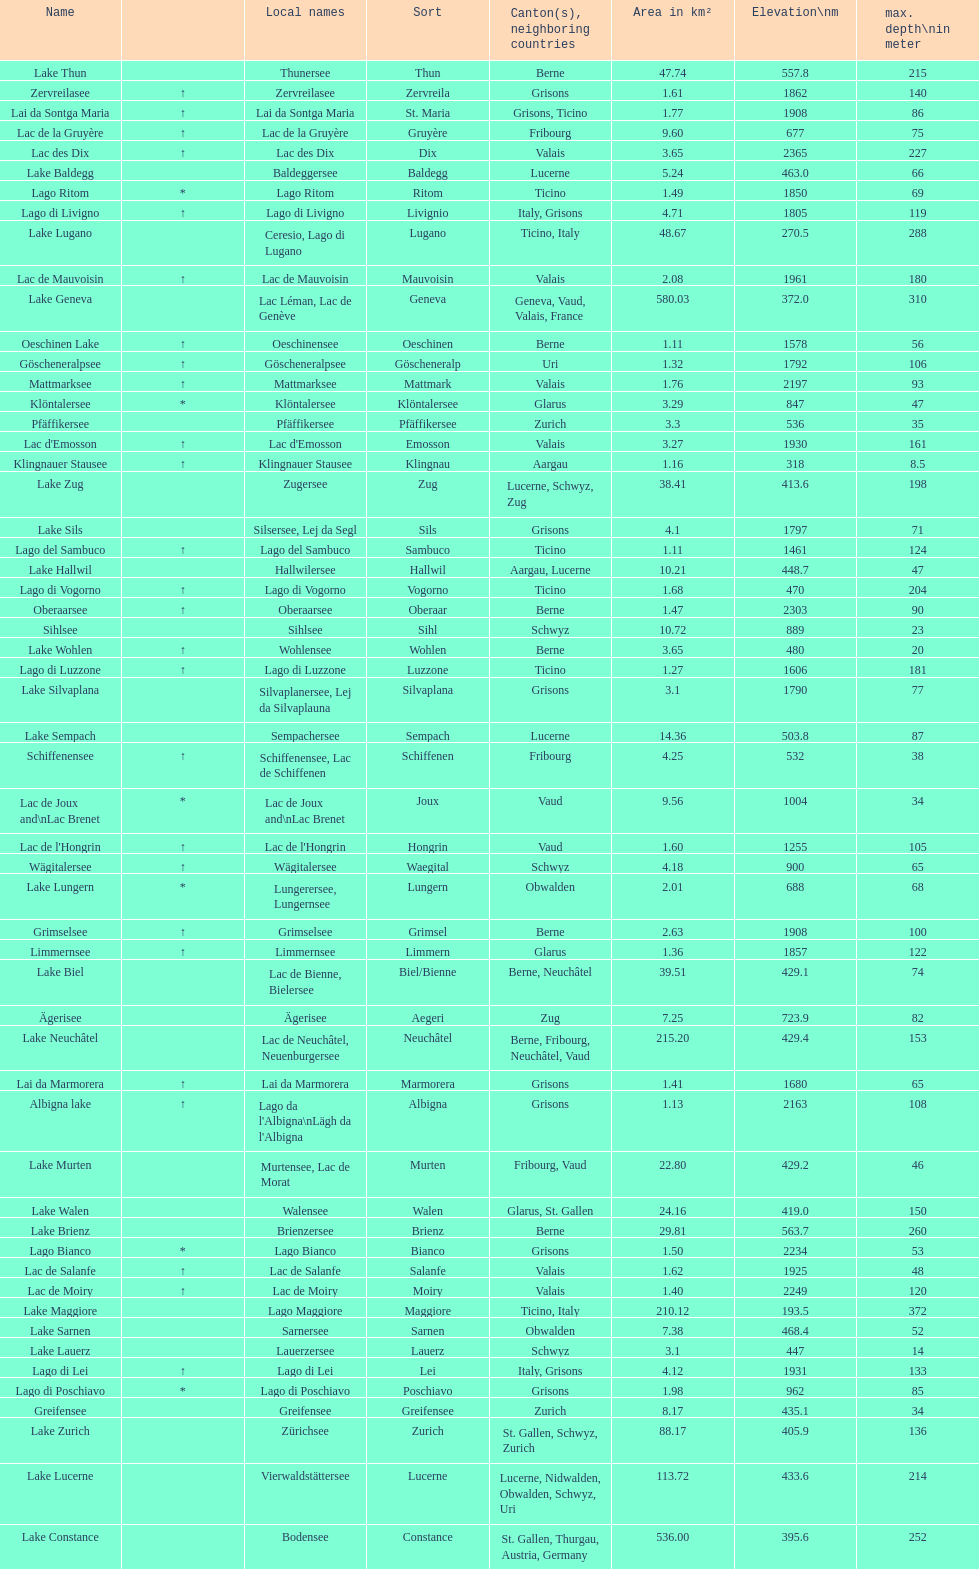Could you parse the entire table as a dict? {'header': ['Name', '', 'Local names', 'Sort', 'Canton(s), neighboring countries', 'Area in km²', 'Elevation\\nm', 'max. depth\\nin meter'], 'rows': [['Lake Thun', '', 'Thunersee', 'Thun', 'Berne', '47.74', '557.8', '215'], ['Zervreilasee', '↑', 'Zervreilasee', 'Zervreila', 'Grisons', '1.61', '1862', '140'], ['Lai da Sontga Maria', '↑', 'Lai da Sontga Maria', 'St. Maria', 'Grisons, Ticino', '1.77', '1908', '86'], ['Lac de la Gruyère', '↑', 'Lac de la Gruyère', 'Gruyère', 'Fribourg', '9.60', '677', '75'], ['Lac des Dix', '↑', 'Lac des Dix', 'Dix', 'Valais', '3.65', '2365', '227'], ['Lake Baldegg', '', 'Baldeggersee', 'Baldegg', 'Lucerne', '5.24', '463.0', '66'], ['Lago Ritom', '*', 'Lago Ritom', 'Ritom', 'Ticino', '1.49', '1850', '69'], ['Lago di Livigno', '↑', 'Lago di Livigno', 'Livignio', 'Italy, Grisons', '4.71', '1805', '119'], ['Lake Lugano', '', 'Ceresio, Lago di Lugano', 'Lugano', 'Ticino, Italy', '48.67', '270.5', '288'], ['Lac de Mauvoisin', '↑', 'Lac de Mauvoisin', 'Mauvoisin', 'Valais', '2.08', '1961', '180'], ['Lake Geneva', '', 'Lac Léman, Lac de Genève', 'Geneva', 'Geneva, Vaud, Valais, France', '580.03', '372.0', '310'], ['Oeschinen Lake', '↑', 'Oeschinensee', 'Oeschinen', 'Berne', '1.11', '1578', '56'], ['Göscheneralpsee', '↑', 'Göscheneralpsee', 'Göscheneralp', 'Uri', '1.32', '1792', '106'], ['Mattmarksee', '↑', 'Mattmarksee', 'Mattmark', 'Valais', '1.76', '2197', '93'], ['Klöntalersee', '*', 'Klöntalersee', 'Klöntalersee', 'Glarus', '3.29', '847', '47'], ['Pfäffikersee', '', 'Pfäffikersee', 'Pfäffikersee', 'Zurich', '3.3', '536', '35'], ["Lac d'Emosson", '↑', "Lac d'Emosson", 'Emosson', 'Valais', '3.27', '1930', '161'], ['Klingnauer Stausee', '↑', 'Klingnauer Stausee', 'Klingnau', 'Aargau', '1.16', '318', '8.5'], ['Lake Zug', '', 'Zugersee', 'Zug', 'Lucerne, Schwyz, Zug', '38.41', '413.6', '198'], ['Lake Sils', '', 'Silsersee, Lej da Segl', 'Sils', 'Grisons', '4.1', '1797', '71'], ['Lago del Sambuco', '↑', 'Lago del Sambuco', 'Sambuco', 'Ticino', '1.11', '1461', '124'], ['Lake Hallwil', '', 'Hallwilersee', 'Hallwil', 'Aargau, Lucerne', '10.21', '448.7', '47'], ['Lago di Vogorno', '↑', 'Lago di Vogorno', 'Vogorno', 'Ticino', '1.68', '470', '204'], ['Oberaarsee', '↑', 'Oberaarsee', 'Oberaar', 'Berne', '1.47', '2303', '90'], ['Sihlsee', '', 'Sihlsee', 'Sihl', 'Schwyz', '10.72', '889', '23'], ['Lake Wohlen', '↑', 'Wohlensee', 'Wohlen', 'Berne', '3.65', '480', '20'], ['Lago di Luzzone', '↑', 'Lago di Luzzone', 'Luzzone', 'Ticino', '1.27', '1606', '181'], ['Lake Silvaplana', '', 'Silvaplanersee, Lej da Silvaplauna', 'Silvaplana', 'Grisons', '3.1', '1790', '77'], ['Lake Sempach', '', 'Sempachersee', 'Sempach', 'Lucerne', '14.36', '503.8', '87'], ['Schiffenensee', '↑', 'Schiffenensee, Lac de Schiffenen', 'Schiffenen', 'Fribourg', '4.25', '532', '38'], ['Lac de Joux and\\nLac Brenet', '*', 'Lac de Joux and\\nLac Brenet', 'Joux', 'Vaud', '9.56', '1004', '34'], ["Lac de l'Hongrin", '↑', "Lac de l'Hongrin", 'Hongrin', 'Vaud', '1.60', '1255', '105'], ['Wägitalersee', '↑', 'Wägitalersee', 'Waegital', 'Schwyz', '4.18', '900', '65'], ['Lake Lungern', '*', 'Lungerersee, Lungernsee', 'Lungern', 'Obwalden', '2.01', '688', '68'], ['Grimselsee', '↑', 'Grimselsee', 'Grimsel', 'Berne', '2.63', '1908', '100'], ['Limmernsee', '↑', 'Limmernsee', 'Limmern', 'Glarus', '1.36', '1857', '122'], ['Lake Biel', '', 'Lac de Bienne, Bielersee', 'Biel/Bienne', 'Berne, Neuchâtel', '39.51', '429.1', '74'], ['Ägerisee', '', 'Ägerisee', 'Aegeri', 'Zug', '7.25', '723.9', '82'], ['Lake Neuchâtel', '', 'Lac de Neuchâtel, Neuenburgersee', 'Neuchâtel', 'Berne, Fribourg, Neuchâtel, Vaud', '215.20', '429.4', '153'], ['Lai da Marmorera', '↑', 'Lai da Marmorera', 'Marmorera', 'Grisons', '1.41', '1680', '65'], ['Albigna lake', '↑', "Lago da l'Albigna\\nLägh da l'Albigna", 'Albigna', 'Grisons', '1.13', '2163', '108'], ['Lake Murten', '', 'Murtensee, Lac de Morat', 'Murten', 'Fribourg, Vaud', '22.80', '429.2', '46'], ['Lake Walen', '', 'Walensee', 'Walen', 'Glarus, St. Gallen', '24.16', '419.0', '150'], ['Lake Brienz', '', 'Brienzersee', 'Brienz', 'Berne', '29.81', '563.7', '260'], ['Lago Bianco', '*', 'Lago Bianco', 'Bianco', 'Grisons', '1.50', '2234', '53'], ['Lac de Salanfe', '↑', 'Lac de Salanfe', 'Salanfe', 'Valais', '1.62', '1925', '48'], ['Lac de Moiry', '↑', 'Lac de Moiry', 'Moiry', 'Valais', '1.40', '2249', '120'], ['Lake Maggiore', '', 'Lago Maggiore', 'Maggiore', 'Ticino, Italy', '210.12', '193.5', '372'], ['Lake Sarnen', '', 'Sarnersee', 'Sarnen', 'Obwalden', '7.38', '468.4', '52'], ['Lake Lauerz', '', 'Lauerzersee', 'Lauerz', 'Schwyz', '3.1', '447', '14'], ['Lago di Lei', '↑', 'Lago di Lei', 'Lei', 'Italy, Grisons', '4.12', '1931', '133'], ['Lago di Poschiavo', '*', 'Lago di Poschiavo', 'Poschiavo', 'Grisons', '1.98', '962', '85'], ['Greifensee', '', 'Greifensee', 'Greifensee', 'Zurich', '8.17', '435.1', '34'], ['Lake Zurich', '', 'Zürichsee', 'Zurich', 'St. Gallen, Schwyz, Zurich', '88.17', '405.9', '136'], ['Lake Lucerne', '', 'Vierwaldstättersee', 'Lucerne', 'Lucerne, Nidwalden, Obwalden, Schwyz, Uri', '113.72', '433.6', '214'], ['Lake Constance', '', 'Bodensee', 'Constance', 'St. Gallen, Thurgau, Austria, Germany', '536.00', '395.6', '252']]} Which lake has the largest elevation? Lac des Dix. 